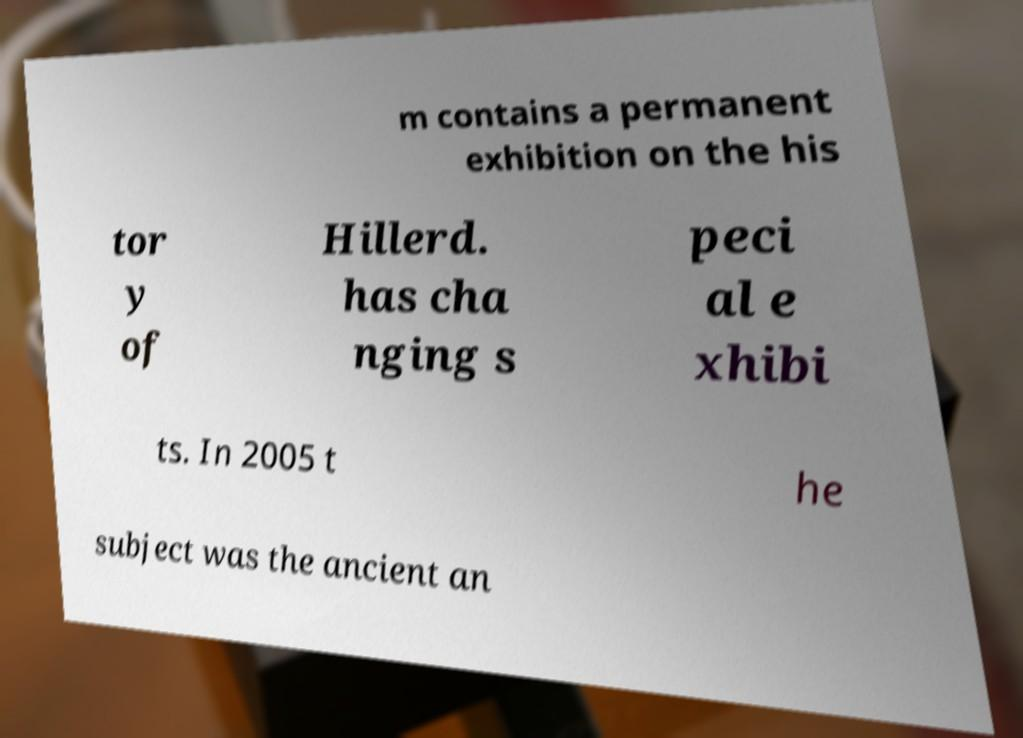Can you read and provide the text displayed in the image?This photo seems to have some interesting text. Can you extract and type it out for me? m contains a permanent exhibition on the his tor y of Hillerd. has cha nging s peci al e xhibi ts. In 2005 t he subject was the ancient an 